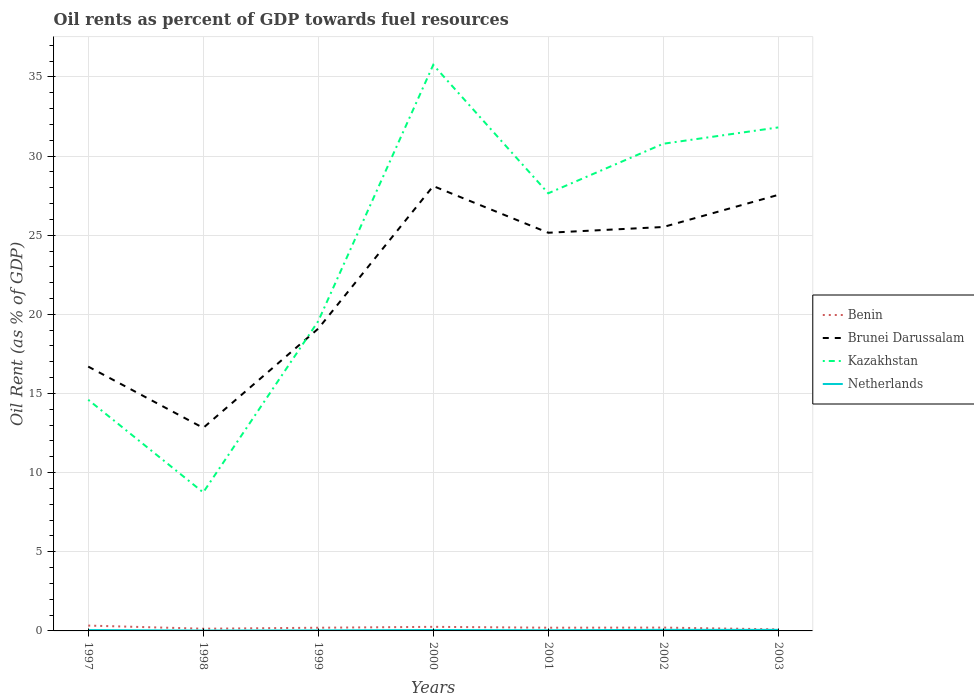Does the line corresponding to Kazakhstan intersect with the line corresponding to Benin?
Give a very brief answer. No. Is the number of lines equal to the number of legend labels?
Your answer should be very brief. Yes. Across all years, what is the maximum oil rent in Brunei Darussalam?
Keep it short and to the point. 12.83. In which year was the oil rent in Brunei Darussalam maximum?
Your answer should be very brief. 1998. What is the total oil rent in Kazakhstan in the graph?
Provide a succinct answer. -12.24. What is the difference between the highest and the second highest oil rent in Kazakhstan?
Keep it short and to the point. 27.01. What is the difference between the highest and the lowest oil rent in Brunei Darussalam?
Your response must be concise. 4. Is the oil rent in Kazakhstan strictly greater than the oil rent in Netherlands over the years?
Ensure brevity in your answer.  No. Does the graph contain any zero values?
Keep it short and to the point. No. Does the graph contain grids?
Make the answer very short. Yes. How many legend labels are there?
Offer a very short reply. 4. What is the title of the graph?
Your answer should be compact. Oil rents as percent of GDP towards fuel resources. Does "Middle income" appear as one of the legend labels in the graph?
Provide a short and direct response. No. What is the label or title of the X-axis?
Provide a short and direct response. Years. What is the label or title of the Y-axis?
Your answer should be very brief. Oil Rent (as % of GDP). What is the Oil Rent (as % of GDP) in Benin in 1997?
Give a very brief answer. 0.34. What is the Oil Rent (as % of GDP) in Brunei Darussalam in 1997?
Offer a very short reply. 16.7. What is the Oil Rent (as % of GDP) of Kazakhstan in 1997?
Offer a very short reply. 14.6. What is the Oil Rent (as % of GDP) in Netherlands in 1997?
Your answer should be very brief. 0.06. What is the Oil Rent (as % of GDP) in Benin in 1998?
Ensure brevity in your answer.  0.14. What is the Oil Rent (as % of GDP) in Brunei Darussalam in 1998?
Make the answer very short. 12.83. What is the Oil Rent (as % of GDP) in Kazakhstan in 1998?
Provide a short and direct response. 8.75. What is the Oil Rent (as % of GDP) in Netherlands in 1998?
Give a very brief answer. 0.02. What is the Oil Rent (as % of GDP) of Benin in 1999?
Offer a very short reply. 0.2. What is the Oil Rent (as % of GDP) in Brunei Darussalam in 1999?
Your answer should be compact. 19.1. What is the Oil Rent (as % of GDP) of Kazakhstan in 1999?
Your response must be concise. 19.57. What is the Oil Rent (as % of GDP) in Netherlands in 1999?
Give a very brief answer. 0.03. What is the Oil Rent (as % of GDP) in Benin in 2000?
Offer a terse response. 0.26. What is the Oil Rent (as % of GDP) of Brunei Darussalam in 2000?
Your response must be concise. 28.1. What is the Oil Rent (as % of GDP) of Kazakhstan in 2000?
Keep it short and to the point. 35.76. What is the Oil Rent (as % of GDP) in Netherlands in 2000?
Your response must be concise. 0.06. What is the Oil Rent (as % of GDP) of Benin in 2001?
Offer a very short reply. 0.2. What is the Oil Rent (as % of GDP) in Brunei Darussalam in 2001?
Provide a succinct answer. 25.15. What is the Oil Rent (as % of GDP) in Kazakhstan in 2001?
Make the answer very short. 27.65. What is the Oil Rent (as % of GDP) of Netherlands in 2001?
Provide a short and direct response. 0.04. What is the Oil Rent (as % of GDP) in Benin in 2002?
Your response must be concise. 0.21. What is the Oil Rent (as % of GDP) of Brunei Darussalam in 2002?
Keep it short and to the point. 25.52. What is the Oil Rent (as % of GDP) in Kazakhstan in 2002?
Keep it short and to the point. 30.78. What is the Oil Rent (as % of GDP) in Netherlands in 2002?
Ensure brevity in your answer.  0.07. What is the Oil Rent (as % of GDP) of Benin in 2003?
Keep it short and to the point. 0.1. What is the Oil Rent (as % of GDP) in Brunei Darussalam in 2003?
Offer a terse response. 27.55. What is the Oil Rent (as % of GDP) of Kazakhstan in 2003?
Provide a short and direct response. 31.81. What is the Oil Rent (as % of GDP) in Netherlands in 2003?
Provide a succinct answer. 0.07. Across all years, what is the maximum Oil Rent (as % of GDP) of Benin?
Your answer should be compact. 0.34. Across all years, what is the maximum Oil Rent (as % of GDP) in Brunei Darussalam?
Give a very brief answer. 28.1. Across all years, what is the maximum Oil Rent (as % of GDP) in Kazakhstan?
Ensure brevity in your answer.  35.76. Across all years, what is the maximum Oil Rent (as % of GDP) of Netherlands?
Offer a terse response. 0.07. Across all years, what is the minimum Oil Rent (as % of GDP) of Benin?
Offer a terse response. 0.1. Across all years, what is the minimum Oil Rent (as % of GDP) in Brunei Darussalam?
Offer a terse response. 12.83. Across all years, what is the minimum Oil Rent (as % of GDP) in Kazakhstan?
Offer a very short reply. 8.75. Across all years, what is the minimum Oil Rent (as % of GDP) in Netherlands?
Your answer should be very brief. 0.02. What is the total Oil Rent (as % of GDP) in Benin in the graph?
Your answer should be very brief. 1.45. What is the total Oil Rent (as % of GDP) of Brunei Darussalam in the graph?
Keep it short and to the point. 154.94. What is the total Oil Rent (as % of GDP) of Kazakhstan in the graph?
Give a very brief answer. 168.91. What is the total Oil Rent (as % of GDP) of Netherlands in the graph?
Offer a terse response. 0.35. What is the difference between the Oil Rent (as % of GDP) in Benin in 1997 and that in 1998?
Give a very brief answer. 0.2. What is the difference between the Oil Rent (as % of GDP) of Brunei Darussalam in 1997 and that in 1998?
Your answer should be compact. 3.87. What is the difference between the Oil Rent (as % of GDP) of Kazakhstan in 1997 and that in 1998?
Give a very brief answer. 5.85. What is the difference between the Oil Rent (as % of GDP) of Netherlands in 1997 and that in 1998?
Your response must be concise. 0.03. What is the difference between the Oil Rent (as % of GDP) of Benin in 1997 and that in 1999?
Ensure brevity in your answer.  0.14. What is the difference between the Oil Rent (as % of GDP) of Brunei Darussalam in 1997 and that in 1999?
Provide a short and direct response. -2.4. What is the difference between the Oil Rent (as % of GDP) in Kazakhstan in 1997 and that in 1999?
Make the answer very short. -4.96. What is the difference between the Oil Rent (as % of GDP) of Netherlands in 1997 and that in 1999?
Your answer should be compact. 0.02. What is the difference between the Oil Rent (as % of GDP) of Benin in 1997 and that in 2000?
Give a very brief answer. 0.08. What is the difference between the Oil Rent (as % of GDP) in Brunei Darussalam in 1997 and that in 2000?
Keep it short and to the point. -11.4. What is the difference between the Oil Rent (as % of GDP) in Kazakhstan in 1997 and that in 2000?
Your response must be concise. -21.16. What is the difference between the Oil Rent (as % of GDP) of Netherlands in 1997 and that in 2000?
Provide a short and direct response. -0. What is the difference between the Oil Rent (as % of GDP) of Benin in 1997 and that in 2001?
Ensure brevity in your answer.  0.13. What is the difference between the Oil Rent (as % of GDP) in Brunei Darussalam in 1997 and that in 2001?
Your response must be concise. -8.46. What is the difference between the Oil Rent (as % of GDP) of Kazakhstan in 1997 and that in 2001?
Give a very brief answer. -13.04. What is the difference between the Oil Rent (as % of GDP) of Netherlands in 1997 and that in 2001?
Give a very brief answer. 0.01. What is the difference between the Oil Rent (as % of GDP) in Benin in 1997 and that in 2002?
Provide a short and direct response. 0.13. What is the difference between the Oil Rent (as % of GDP) of Brunei Darussalam in 1997 and that in 2002?
Provide a short and direct response. -8.82. What is the difference between the Oil Rent (as % of GDP) in Kazakhstan in 1997 and that in 2002?
Keep it short and to the point. -16.17. What is the difference between the Oil Rent (as % of GDP) in Netherlands in 1997 and that in 2002?
Make the answer very short. -0.01. What is the difference between the Oil Rent (as % of GDP) in Benin in 1997 and that in 2003?
Your answer should be very brief. 0.24. What is the difference between the Oil Rent (as % of GDP) in Brunei Darussalam in 1997 and that in 2003?
Give a very brief answer. -10.85. What is the difference between the Oil Rent (as % of GDP) in Kazakhstan in 1997 and that in 2003?
Your answer should be compact. -17.2. What is the difference between the Oil Rent (as % of GDP) in Netherlands in 1997 and that in 2003?
Offer a very short reply. -0.01. What is the difference between the Oil Rent (as % of GDP) in Benin in 1998 and that in 1999?
Offer a terse response. -0.06. What is the difference between the Oil Rent (as % of GDP) of Brunei Darussalam in 1998 and that in 1999?
Provide a succinct answer. -6.27. What is the difference between the Oil Rent (as % of GDP) of Kazakhstan in 1998 and that in 1999?
Provide a short and direct response. -10.82. What is the difference between the Oil Rent (as % of GDP) of Netherlands in 1998 and that in 1999?
Your response must be concise. -0.01. What is the difference between the Oil Rent (as % of GDP) in Benin in 1998 and that in 2000?
Give a very brief answer. -0.12. What is the difference between the Oil Rent (as % of GDP) of Brunei Darussalam in 1998 and that in 2000?
Provide a succinct answer. -15.28. What is the difference between the Oil Rent (as % of GDP) in Kazakhstan in 1998 and that in 2000?
Keep it short and to the point. -27.01. What is the difference between the Oil Rent (as % of GDP) in Netherlands in 1998 and that in 2000?
Keep it short and to the point. -0.03. What is the difference between the Oil Rent (as % of GDP) of Benin in 1998 and that in 2001?
Your answer should be very brief. -0.06. What is the difference between the Oil Rent (as % of GDP) in Brunei Darussalam in 1998 and that in 2001?
Make the answer very short. -12.33. What is the difference between the Oil Rent (as % of GDP) of Kazakhstan in 1998 and that in 2001?
Provide a short and direct response. -18.9. What is the difference between the Oil Rent (as % of GDP) of Netherlands in 1998 and that in 2001?
Ensure brevity in your answer.  -0.02. What is the difference between the Oil Rent (as % of GDP) of Benin in 1998 and that in 2002?
Your response must be concise. -0.07. What is the difference between the Oil Rent (as % of GDP) of Brunei Darussalam in 1998 and that in 2002?
Your answer should be very brief. -12.69. What is the difference between the Oil Rent (as % of GDP) in Kazakhstan in 1998 and that in 2002?
Your answer should be very brief. -22.03. What is the difference between the Oil Rent (as % of GDP) in Netherlands in 1998 and that in 2002?
Keep it short and to the point. -0.04. What is the difference between the Oil Rent (as % of GDP) in Benin in 1998 and that in 2003?
Your response must be concise. 0.04. What is the difference between the Oil Rent (as % of GDP) in Brunei Darussalam in 1998 and that in 2003?
Give a very brief answer. -14.72. What is the difference between the Oil Rent (as % of GDP) in Kazakhstan in 1998 and that in 2003?
Offer a terse response. -23.06. What is the difference between the Oil Rent (as % of GDP) in Netherlands in 1998 and that in 2003?
Keep it short and to the point. -0.04. What is the difference between the Oil Rent (as % of GDP) of Benin in 1999 and that in 2000?
Give a very brief answer. -0.06. What is the difference between the Oil Rent (as % of GDP) in Brunei Darussalam in 1999 and that in 2000?
Your answer should be very brief. -9.01. What is the difference between the Oil Rent (as % of GDP) of Kazakhstan in 1999 and that in 2000?
Make the answer very short. -16.19. What is the difference between the Oil Rent (as % of GDP) in Netherlands in 1999 and that in 2000?
Keep it short and to the point. -0.03. What is the difference between the Oil Rent (as % of GDP) of Benin in 1999 and that in 2001?
Your answer should be compact. -0. What is the difference between the Oil Rent (as % of GDP) of Brunei Darussalam in 1999 and that in 2001?
Your answer should be very brief. -6.06. What is the difference between the Oil Rent (as % of GDP) in Kazakhstan in 1999 and that in 2001?
Provide a succinct answer. -8.08. What is the difference between the Oil Rent (as % of GDP) in Netherlands in 1999 and that in 2001?
Offer a very short reply. -0.01. What is the difference between the Oil Rent (as % of GDP) of Benin in 1999 and that in 2002?
Provide a succinct answer. -0.01. What is the difference between the Oil Rent (as % of GDP) in Brunei Darussalam in 1999 and that in 2002?
Provide a short and direct response. -6.42. What is the difference between the Oil Rent (as % of GDP) in Kazakhstan in 1999 and that in 2002?
Keep it short and to the point. -11.21. What is the difference between the Oil Rent (as % of GDP) of Netherlands in 1999 and that in 2002?
Offer a very short reply. -0.03. What is the difference between the Oil Rent (as % of GDP) of Benin in 1999 and that in 2003?
Offer a terse response. 0.1. What is the difference between the Oil Rent (as % of GDP) in Brunei Darussalam in 1999 and that in 2003?
Give a very brief answer. -8.45. What is the difference between the Oil Rent (as % of GDP) in Kazakhstan in 1999 and that in 2003?
Your answer should be compact. -12.24. What is the difference between the Oil Rent (as % of GDP) of Netherlands in 1999 and that in 2003?
Your answer should be very brief. -0.03. What is the difference between the Oil Rent (as % of GDP) of Benin in 2000 and that in 2001?
Provide a succinct answer. 0.05. What is the difference between the Oil Rent (as % of GDP) in Brunei Darussalam in 2000 and that in 2001?
Ensure brevity in your answer.  2.95. What is the difference between the Oil Rent (as % of GDP) of Kazakhstan in 2000 and that in 2001?
Provide a short and direct response. 8.11. What is the difference between the Oil Rent (as % of GDP) in Netherlands in 2000 and that in 2001?
Offer a very short reply. 0.01. What is the difference between the Oil Rent (as % of GDP) of Benin in 2000 and that in 2002?
Your answer should be compact. 0.05. What is the difference between the Oil Rent (as % of GDP) in Brunei Darussalam in 2000 and that in 2002?
Your response must be concise. 2.59. What is the difference between the Oil Rent (as % of GDP) in Kazakhstan in 2000 and that in 2002?
Offer a terse response. 4.98. What is the difference between the Oil Rent (as % of GDP) of Netherlands in 2000 and that in 2002?
Offer a very short reply. -0.01. What is the difference between the Oil Rent (as % of GDP) of Benin in 2000 and that in 2003?
Give a very brief answer. 0.16. What is the difference between the Oil Rent (as % of GDP) of Brunei Darussalam in 2000 and that in 2003?
Provide a short and direct response. 0.56. What is the difference between the Oil Rent (as % of GDP) in Kazakhstan in 2000 and that in 2003?
Offer a terse response. 3.95. What is the difference between the Oil Rent (as % of GDP) of Netherlands in 2000 and that in 2003?
Keep it short and to the point. -0.01. What is the difference between the Oil Rent (as % of GDP) in Benin in 2001 and that in 2002?
Provide a short and direct response. -0.01. What is the difference between the Oil Rent (as % of GDP) of Brunei Darussalam in 2001 and that in 2002?
Offer a very short reply. -0.36. What is the difference between the Oil Rent (as % of GDP) of Kazakhstan in 2001 and that in 2002?
Keep it short and to the point. -3.13. What is the difference between the Oil Rent (as % of GDP) in Netherlands in 2001 and that in 2002?
Keep it short and to the point. -0.02. What is the difference between the Oil Rent (as % of GDP) of Benin in 2001 and that in 2003?
Your answer should be compact. 0.1. What is the difference between the Oil Rent (as % of GDP) of Brunei Darussalam in 2001 and that in 2003?
Your answer should be compact. -2.39. What is the difference between the Oil Rent (as % of GDP) of Kazakhstan in 2001 and that in 2003?
Give a very brief answer. -4.16. What is the difference between the Oil Rent (as % of GDP) in Netherlands in 2001 and that in 2003?
Offer a terse response. -0.02. What is the difference between the Oil Rent (as % of GDP) of Benin in 2002 and that in 2003?
Give a very brief answer. 0.11. What is the difference between the Oil Rent (as % of GDP) in Brunei Darussalam in 2002 and that in 2003?
Give a very brief answer. -2.03. What is the difference between the Oil Rent (as % of GDP) of Kazakhstan in 2002 and that in 2003?
Offer a terse response. -1.03. What is the difference between the Oil Rent (as % of GDP) in Netherlands in 2002 and that in 2003?
Your answer should be very brief. -0. What is the difference between the Oil Rent (as % of GDP) in Benin in 1997 and the Oil Rent (as % of GDP) in Brunei Darussalam in 1998?
Your answer should be very brief. -12.49. What is the difference between the Oil Rent (as % of GDP) in Benin in 1997 and the Oil Rent (as % of GDP) in Kazakhstan in 1998?
Your answer should be compact. -8.41. What is the difference between the Oil Rent (as % of GDP) of Benin in 1997 and the Oil Rent (as % of GDP) of Netherlands in 1998?
Offer a very short reply. 0.31. What is the difference between the Oil Rent (as % of GDP) of Brunei Darussalam in 1997 and the Oil Rent (as % of GDP) of Kazakhstan in 1998?
Your answer should be compact. 7.95. What is the difference between the Oil Rent (as % of GDP) in Brunei Darussalam in 1997 and the Oil Rent (as % of GDP) in Netherlands in 1998?
Offer a very short reply. 16.68. What is the difference between the Oil Rent (as % of GDP) of Kazakhstan in 1997 and the Oil Rent (as % of GDP) of Netherlands in 1998?
Offer a terse response. 14.58. What is the difference between the Oil Rent (as % of GDP) of Benin in 1997 and the Oil Rent (as % of GDP) of Brunei Darussalam in 1999?
Your response must be concise. -18.76. What is the difference between the Oil Rent (as % of GDP) in Benin in 1997 and the Oil Rent (as % of GDP) in Kazakhstan in 1999?
Offer a very short reply. -19.23. What is the difference between the Oil Rent (as % of GDP) of Benin in 1997 and the Oil Rent (as % of GDP) of Netherlands in 1999?
Your answer should be very brief. 0.3. What is the difference between the Oil Rent (as % of GDP) of Brunei Darussalam in 1997 and the Oil Rent (as % of GDP) of Kazakhstan in 1999?
Provide a short and direct response. -2.87. What is the difference between the Oil Rent (as % of GDP) in Brunei Darussalam in 1997 and the Oil Rent (as % of GDP) in Netherlands in 1999?
Offer a very short reply. 16.67. What is the difference between the Oil Rent (as % of GDP) of Kazakhstan in 1997 and the Oil Rent (as % of GDP) of Netherlands in 1999?
Keep it short and to the point. 14.57. What is the difference between the Oil Rent (as % of GDP) of Benin in 1997 and the Oil Rent (as % of GDP) of Brunei Darussalam in 2000?
Your response must be concise. -27.77. What is the difference between the Oil Rent (as % of GDP) of Benin in 1997 and the Oil Rent (as % of GDP) of Kazakhstan in 2000?
Provide a succinct answer. -35.42. What is the difference between the Oil Rent (as % of GDP) in Benin in 1997 and the Oil Rent (as % of GDP) in Netherlands in 2000?
Provide a succinct answer. 0.28. What is the difference between the Oil Rent (as % of GDP) of Brunei Darussalam in 1997 and the Oil Rent (as % of GDP) of Kazakhstan in 2000?
Provide a succinct answer. -19.06. What is the difference between the Oil Rent (as % of GDP) of Brunei Darussalam in 1997 and the Oil Rent (as % of GDP) of Netherlands in 2000?
Your response must be concise. 16.64. What is the difference between the Oil Rent (as % of GDP) of Kazakhstan in 1997 and the Oil Rent (as % of GDP) of Netherlands in 2000?
Your answer should be very brief. 14.55. What is the difference between the Oil Rent (as % of GDP) in Benin in 1997 and the Oil Rent (as % of GDP) in Brunei Darussalam in 2001?
Your response must be concise. -24.82. What is the difference between the Oil Rent (as % of GDP) in Benin in 1997 and the Oil Rent (as % of GDP) in Kazakhstan in 2001?
Provide a succinct answer. -27.31. What is the difference between the Oil Rent (as % of GDP) in Benin in 1997 and the Oil Rent (as % of GDP) in Netherlands in 2001?
Offer a terse response. 0.29. What is the difference between the Oil Rent (as % of GDP) of Brunei Darussalam in 1997 and the Oil Rent (as % of GDP) of Kazakhstan in 2001?
Offer a very short reply. -10.95. What is the difference between the Oil Rent (as % of GDP) in Brunei Darussalam in 1997 and the Oil Rent (as % of GDP) in Netherlands in 2001?
Your answer should be very brief. 16.66. What is the difference between the Oil Rent (as % of GDP) in Kazakhstan in 1997 and the Oil Rent (as % of GDP) in Netherlands in 2001?
Offer a very short reply. 14.56. What is the difference between the Oil Rent (as % of GDP) of Benin in 1997 and the Oil Rent (as % of GDP) of Brunei Darussalam in 2002?
Your response must be concise. -25.18. What is the difference between the Oil Rent (as % of GDP) in Benin in 1997 and the Oil Rent (as % of GDP) in Kazakhstan in 2002?
Your answer should be compact. -30.44. What is the difference between the Oil Rent (as % of GDP) of Benin in 1997 and the Oil Rent (as % of GDP) of Netherlands in 2002?
Ensure brevity in your answer.  0.27. What is the difference between the Oil Rent (as % of GDP) of Brunei Darussalam in 1997 and the Oil Rent (as % of GDP) of Kazakhstan in 2002?
Provide a short and direct response. -14.08. What is the difference between the Oil Rent (as % of GDP) of Brunei Darussalam in 1997 and the Oil Rent (as % of GDP) of Netherlands in 2002?
Ensure brevity in your answer.  16.63. What is the difference between the Oil Rent (as % of GDP) of Kazakhstan in 1997 and the Oil Rent (as % of GDP) of Netherlands in 2002?
Your answer should be very brief. 14.54. What is the difference between the Oil Rent (as % of GDP) of Benin in 1997 and the Oil Rent (as % of GDP) of Brunei Darussalam in 2003?
Your answer should be very brief. -27.21. What is the difference between the Oil Rent (as % of GDP) in Benin in 1997 and the Oil Rent (as % of GDP) in Kazakhstan in 2003?
Provide a short and direct response. -31.47. What is the difference between the Oil Rent (as % of GDP) of Benin in 1997 and the Oil Rent (as % of GDP) of Netherlands in 2003?
Ensure brevity in your answer.  0.27. What is the difference between the Oil Rent (as % of GDP) of Brunei Darussalam in 1997 and the Oil Rent (as % of GDP) of Kazakhstan in 2003?
Offer a very short reply. -15.11. What is the difference between the Oil Rent (as % of GDP) in Brunei Darussalam in 1997 and the Oil Rent (as % of GDP) in Netherlands in 2003?
Provide a short and direct response. 16.63. What is the difference between the Oil Rent (as % of GDP) of Kazakhstan in 1997 and the Oil Rent (as % of GDP) of Netherlands in 2003?
Provide a short and direct response. 14.54. What is the difference between the Oil Rent (as % of GDP) in Benin in 1998 and the Oil Rent (as % of GDP) in Brunei Darussalam in 1999?
Offer a very short reply. -18.96. What is the difference between the Oil Rent (as % of GDP) in Benin in 1998 and the Oil Rent (as % of GDP) in Kazakhstan in 1999?
Provide a short and direct response. -19.43. What is the difference between the Oil Rent (as % of GDP) of Benin in 1998 and the Oil Rent (as % of GDP) of Netherlands in 1999?
Your answer should be very brief. 0.11. What is the difference between the Oil Rent (as % of GDP) of Brunei Darussalam in 1998 and the Oil Rent (as % of GDP) of Kazakhstan in 1999?
Give a very brief answer. -6.74. What is the difference between the Oil Rent (as % of GDP) of Brunei Darussalam in 1998 and the Oil Rent (as % of GDP) of Netherlands in 1999?
Offer a terse response. 12.79. What is the difference between the Oil Rent (as % of GDP) of Kazakhstan in 1998 and the Oil Rent (as % of GDP) of Netherlands in 1999?
Keep it short and to the point. 8.72. What is the difference between the Oil Rent (as % of GDP) of Benin in 1998 and the Oil Rent (as % of GDP) of Brunei Darussalam in 2000?
Give a very brief answer. -27.96. What is the difference between the Oil Rent (as % of GDP) of Benin in 1998 and the Oil Rent (as % of GDP) of Kazakhstan in 2000?
Your answer should be very brief. -35.62. What is the difference between the Oil Rent (as % of GDP) in Benin in 1998 and the Oil Rent (as % of GDP) in Netherlands in 2000?
Your answer should be compact. 0.08. What is the difference between the Oil Rent (as % of GDP) in Brunei Darussalam in 1998 and the Oil Rent (as % of GDP) in Kazakhstan in 2000?
Offer a terse response. -22.93. What is the difference between the Oil Rent (as % of GDP) of Brunei Darussalam in 1998 and the Oil Rent (as % of GDP) of Netherlands in 2000?
Offer a very short reply. 12.77. What is the difference between the Oil Rent (as % of GDP) of Kazakhstan in 1998 and the Oil Rent (as % of GDP) of Netherlands in 2000?
Your response must be concise. 8.69. What is the difference between the Oil Rent (as % of GDP) of Benin in 1998 and the Oil Rent (as % of GDP) of Brunei Darussalam in 2001?
Your answer should be very brief. -25.01. What is the difference between the Oil Rent (as % of GDP) of Benin in 1998 and the Oil Rent (as % of GDP) of Kazakhstan in 2001?
Offer a terse response. -27.51. What is the difference between the Oil Rent (as % of GDP) in Benin in 1998 and the Oil Rent (as % of GDP) in Netherlands in 2001?
Provide a succinct answer. 0.1. What is the difference between the Oil Rent (as % of GDP) of Brunei Darussalam in 1998 and the Oil Rent (as % of GDP) of Kazakhstan in 2001?
Make the answer very short. -14.82. What is the difference between the Oil Rent (as % of GDP) of Brunei Darussalam in 1998 and the Oil Rent (as % of GDP) of Netherlands in 2001?
Offer a very short reply. 12.78. What is the difference between the Oil Rent (as % of GDP) of Kazakhstan in 1998 and the Oil Rent (as % of GDP) of Netherlands in 2001?
Offer a very short reply. 8.71. What is the difference between the Oil Rent (as % of GDP) of Benin in 1998 and the Oil Rent (as % of GDP) of Brunei Darussalam in 2002?
Keep it short and to the point. -25.38. What is the difference between the Oil Rent (as % of GDP) in Benin in 1998 and the Oil Rent (as % of GDP) in Kazakhstan in 2002?
Offer a very short reply. -30.64. What is the difference between the Oil Rent (as % of GDP) in Benin in 1998 and the Oil Rent (as % of GDP) in Netherlands in 2002?
Ensure brevity in your answer.  0.07. What is the difference between the Oil Rent (as % of GDP) of Brunei Darussalam in 1998 and the Oil Rent (as % of GDP) of Kazakhstan in 2002?
Give a very brief answer. -17.95. What is the difference between the Oil Rent (as % of GDP) in Brunei Darussalam in 1998 and the Oil Rent (as % of GDP) in Netherlands in 2002?
Offer a very short reply. 12.76. What is the difference between the Oil Rent (as % of GDP) in Kazakhstan in 1998 and the Oil Rent (as % of GDP) in Netherlands in 2002?
Ensure brevity in your answer.  8.68. What is the difference between the Oil Rent (as % of GDP) in Benin in 1998 and the Oil Rent (as % of GDP) in Brunei Darussalam in 2003?
Keep it short and to the point. -27.41. What is the difference between the Oil Rent (as % of GDP) in Benin in 1998 and the Oil Rent (as % of GDP) in Kazakhstan in 2003?
Provide a succinct answer. -31.67. What is the difference between the Oil Rent (as % of GDP) in Benin in 1998 and the Oil Rent (as % of GDP) in Netherlands in 2003?
Provide a short and direct response. 0.07. What is the difference between the Oil Rent (as % of GDP) in Brunei Darussalam in 1998 and the Oil Rent (as % of GDP) in Kazakhstan in 2003?
Your answer should be compact. -18.98. What is the difference between the Oil Rent (as % of GDP) in Brunei Darussalam in 1998 and the Oil Rent (as % of GDP) in Netherlands in 2003?
Your response must be concise. 12.76. What is the difference between the Oil Rent (as % of GDP) in Kazakhstan in 1998 and the Oil Rent (as % of GDP) in Netherlands in 2003?
Your response must be concise. 8.68. What is the difference between the Oil Rent (as % of GDP) of Benin in 1999 and the Oil Rent (as % of GDP) of Brunei Darussalam in 2000?
Your answer should be very brief. -27.9. What is the difference between the Oil Rent (as % of GDP) of Benin in 1999 and the Oil Rent (as % of GDP) of Kazakhstan in 2000?
Keep it short and to the point. -35.56. What is the difference between the Oil Rent (as % of GDP) in Benin in 1999 and the Oil Rent (as % of GDP) in Netherlands in 2000?
Your answer should be very brief. 0.14. What is the difference between the Oil Rent (as % of GDP) of Brunei Darussalam in 1999 and the Oil Rent (as % of GDP) of Kazakhstan in 2000?
Give a very brief answer. -16.66. What is the difference between the Oil Rent (as % of GDP) of Brunei Darussalam in 1999 and the Oil Rent (as % of GDP) of Netherlands in 2000?
Your answer should be compact. 19.04. What is the difference between the Oil Rent (as % of GDP) of Kazakhstan in 1999 and the Oil Rent (as % of GDP) of Netherlands in 2000?
Your answer should be very brief. 19.51. What is the difference between the Oil Rent (as % of GDP) in Benin in 1999 and the Oil Rent (as % of GDP) in Brunei Darussalam in 2001?
Keep it short and to the point. -24.95. What is the difference between the Oil Rent (as % of GDP) of Benin in 1999 and the Oil Rent (as % of GDP) of Kazakhstan in 2001?
Provide a short and direct response. -27.45. What is the difference between the Oil Rent (as % of GDP) in Benin in 1999 and the Oil Rent (as % of GDP) in Netherlands in 2001?
Offer a terse response. 0.16. What is the difference between the Oil Rent (as % of GDP) in Brunei Darussalam in 1999 and the Oil Rent (as % of GDP) in Kazakhstan in 2001?
Your response must be concise. -8.55. What is the difference between the Oil Rent (as % of GDP) of Brunei Darussalam in 1999 and the Oil Rent (as % of GDP) of Netherlands in 2001?
Offer a terse response. 19.05. What is the difference between the Oil Rent (as % of GDP) of Kazakhstan in 1999 and the Oil Rent (as % of GDP) of Netherlands in 2001?
Offer a terse response. 19.52. What is the difference between the Oil Rent (as % of GDP) in Benin in 1999 and the Oil Rent (as % of GDP) in Brunei Darussalam in 2002?
Your answer should be very brief. -25.32. What is the difference between the Oil Rent (as % of GDP) in Benin in 1999 and the Oil Rent (as % of GDP) in Kazakhstan in 2002?
Provide a short and direct response. -30.58. What is the difference between the Oil Rent (as % of GDP) in Benin in 1999 and the Oil Rent (as % of GDP) in Netherlands in 2002?
Your response must be concise. 0.13. What is the difference between the Oil Rent (as % of GDP) of Brunei Darussalam in 1999 and the Oil Rent (as % of GDP) of Kazakhstan in 2002?
Ensure brevity in your answer.  -11.68. What is the difference between the Oil Rent (as % of GDP) of Brunei Darussalam in 1999 and the Oil Rent (as % of GDP) of Netherlands in 2002?
Ensure brevity in your answer.  19.03. What is the difference between the Oil Rent (as % of GDP) of Kazakhstan in 1999 and the Oil Rent (as % of GDP) of Netherlands in 2002?
Offer a terse response. 19.5. What is the difference between the Oil Rent (as % of GDP) in Benin in 1999 and the Oil Rent (as % of GDP) in Brunei Darussalam in 2003?
Your answer should be very brief. -27.35. What is the difference between the Oil Rent (as % of GDP) of Benin in 1999 and the Oil Rent (as % of GDP) of Kazakhstan in 2003?
Ensure brevity in your answer.  -31.61. What is the difference between the Oil Rent (as % of GDP) of Benin in 1999 and the Oil Rent (as % of GDP) of Netherlands in 2003?
Ensure brevity in your answer.  0.13. What is the difference between the Oil Rent (as % of GDP) of Brunei Darussalam in 1999 and the Oil Rent (as % of GDP) of Kazakhstan in 2003?
Provide a succinct answer. -12.71. What is the difference between the Oil Rent (as % of GDP) of Brunei Darussalam in 1999 and the Oil Rent (as % of GDP) of Netherlands in 2003?
Make the answer very short. 19.03. What is the difference between the Oil Rent (as % of GDP) of Kazakhstan in 1999 and the Oil Rent (as % of GDP) of Netherlands in 2003?
Offer a very short reply. 19.5. What is the difference between the Oil Rent (as % of GDP) in Benin in 2000 and the Oil Rent (as % of GDP) in Brunei Darussalam in 2001?
Your answer should be very brief. -24.9. What is the difference between the Oil Rent (as % of GDP) of Benin in 2000 and the Oil Rent (as % of GDP) of Kazakhstan in 2001?
Provide a succinct answer. -27.39. What is the difference between the Oil Rent (as % of GDP) of Benin in 2000 and the Oil Rent (as % of GDP) of Netherlands in 2001?
Provide a short and direct response. 0.21. What is the difference between the Oil Rent (as % of GDP) of Brunei Darussalam in 2000 and the Oil Rent (as % of GDP) of Kazakhstan in 2001?
Your response must be concise. 0.46. What is the difference between the Oil Rent (as % of GDP) of Brunei Darussalam in 2000 and the Oil Rent (as % of GDP) of Netherlands in 2001?
Your response must be concise. 28.06. What is the difference between the Oil Rent (as % of GDP) of Kazakhstan in 2000 and the Oil Rent (as % of GDP) of Netherlands in 2001?
Your response must be concise. 35.72. What is the difference between the Oil Rent (as % of GDP) in Benin in 2000 and the Oil Rent (as % of GDP) in Brunei Darussalam in 2002?
Provide a short and direct response. -25.26. What is the difference between the Oil Rent (as % of GDP) of Benin in 2000 and the Oil Rent (as % of GDP) of Kazakhstan in 2002?
Keep it short and to the point. -30.52. What is the difference between the Oil Rent (as % of GDP) of Benin in 2000 and the Oil Rent (as % of GDP) of Netherlands in 2002?
Make the answer very short. 0.19. What is the difference between the Oil Rent (as % of GDP) in Brunei Darussalam in 2000 and the Oil Rent (as % of GDP) in Kazakhstan in 2002?
Provide a short and direct response. -2.67. What is the difference between the Oil Rent (as % of GDP) in Brunei Darussalam in 2000 and the Oil Rent (as % of GDP) in Netherlands in 2002?
Ensure brevity in your answer.  28.04. What is the difference between the Oil Rent (as % of GDP) in Kazakhstan in 2000 and the Oil Rent (as % of GDP) in Netherlands in 2002?
Provide a succinct answer. 35.69. What is the difference between the Oil Rent (as % of GDP) of Benin in 2000 and the Oil Rent (as % of GDP) of Brunei Darussalam in 2003?
Provide a succinct answer. -27.29. What is the difference between the Oil Rent (as % of GDP) of Benin in 2000 and the Oil Rent (as % of GDP) of Kazakhstan in 2003?
Keep it short and to the point. -31.55. What is the difference between the Oil Rent (as % of GDP) in Benin in 2000 and the Oil Rent (as % of GDP) in Netherlands in 2003?
Your response must be concise. 0.19. What is the difference between the Oil Rent (as % of GDP) in Brunei Darussalam in 2000 and the Oil Rent (as % of GDP) in Kazakhstan in 2003?
Keep it short and to the point. -3.7. What is the difference between the Oil Rent (as % of GDP) in Brunei Darussalam in 2000 and the Oil Rent (as % of GDP) in Netherlands in 2003?
Offer a terse response. 28.04. What is the difference between the Oil Rent (as % of GDP) of Kazakhstan in 2000 and the Oil Rent (as % of GDP) of Netherlands in 2003?
Keep it short and to the point. 35.69. What is the difference between the Oil Rent (as % of GDP) of Benin in 2001 and the Oil Rent (as % of GDP) of Brunei Darussalam in 2002?
Give a very brief answer. -25.31. What is the difference between the Oil Rent (as % of GDP) of Benin in 2001 and the Oil Rent (as % of GDP) of Kazakhstan in 2002?
Your answer should be very brief. -30.57. What is the difference between the Oil Rent (as % of GDP) of Benin in 2001 and the Oil Rent (as % of GDP) of Netherlands in 2002?
Give a very brief answer. 0.14. What is the difference between the Oil Rent (as % of GDP) in Brunei Darussalam in 2001 and the Oil Rent (as % of GDP) in Kazakhstan in 2002?
Offer a very short reply. -5.62. What is the difference between the Oil Rent (as % of GDP) in Brunei Darussalam in 2001 and the Oil Rent (as % of GDP) in Netherlands in 2002?
Provide a succinct answer. 25.09. What is the difference between the Oil Rent (as % of GDP) in Kazakhstan in 2001 and the Oil Rent (as % of GDP) in Netherlands in 2002?
Keep it short and to the point. 27.58. What is the difference between the Oil Rent (as % of GDP) in Benin in 2001 and the Oil Rent (as % of GDP) in Brunei Darussalam in 2003?
Keep it short and to the point. -27.34. What is the difference between the Oil Rent (as % of GDP) in Benin in 2001 and the Oil Rent (as % of GDP) in Kazakhstan in 2003?
Your answer should be very brief. -31.6. What is the difference between the Oil Rent (as % of GDP) of Benin in 2001 and the Oil Rent (as % of GDP) of Netherlands in 2003?
Provide a short and direct response. 0.14. What is the difference between the Oil Rent (as % of GDP) of Brunei Darussalam in 2001 and the Oil Rent (as % of GDP) of Kazakhstan in 2003?
Offer a terse response. -6.65. What is the difference between the Oil Rent (as % of GDP) in Brunei Darussalam in 2001 and the Oil Rent (as % of GDP) in Netherlands in 2003?
Ensure brevity in your answer.  25.09. What is the difference between the Oil Rent (as % of GDP) in Kazakhstan in 2001 and the Oil Rent (as % of GDP) in Netherlands in 2003?
Your response must be concise. 27.58. What is the difference between the Oil Rent (as % of GDP) in Benin in 2002 and the Oil Rent (as % of GDP) in Brunei Darussalam in 2003?
Give a very brief answer. -27.34. What is the difference between the Oil Rent (as % of GDP) of Benin in 2002 and the Oil Rent (as % of GDP) of Kazakhstan in 2003?
Provide a succinct answer. -31.6. What is the difference between the Oil Rent (as % of GDP) in Benin in 2002 and the Oil Rent (as % of GDP) in Netherlands in 2003?
Keep it short and to the point. 0.14. What is the difference between the Oil Rent (as % of GDP) of Brunei Darussalam in 2002 and the Oil Rent (as % of GDP) of Kazakhstan in 2003?
Keep it short and to the point. -6.29. What is the difference between the Oil Rent (as % of GDP) of Brunei Darussalam in 2002 and the Oil Rent (as % of GDP) of Netherlands in 2003?
Give a very brief answer. 25.45. What is the difference between the Oil Rent (as % of GDP) in Kazakhstan in 2002 and the Oil Rent (as % of GDP) in Netherlands in 2003?
Your answer should be compact. 30.71. What is the average Oil Rent (as % of GDP) in Benin per year?
Provide a short and direct response. 0.21. What is the average Oil Rent (as % of GDP) in Brunei Darussalam per year?
Ensure brevity in your answer.  22.13. What is the average Oil Rent (as % of GDP) in Kazakhstan per year?
Your answer should be very brief. 24.13. What is the average Oil Rent (as % of GDP) in Netherlands per year?
Provide a short and direct response. 0.05. In the year 1997, what is the difference between the Oil Rent (as % of GDP) in Benin and Oil Rent (as % of GDP) in Brunei Darussalam?
Offer a terse response. -16.36. In the year 1997, what is the difference between the Oil Rent (as % of GDP) in Benin and Oil Rent (as % of GDP) in Kazakhstan?
Your response must be concise. -14.27. In the year 1997, what is the difference between the Oil Rent (as % of GDP) of Benin and Oil Rent (as % of GDP) of Netherlands?
Keep it short and to the point. 0.28. In the year 1997, what is the difference between the Oil Rent (as % of GDP) of Brunei Darussalam and Oil Rent (as % of GDP) of Kazakhstan?
Keep it short and to the point. 2.1. In the year 1997, what is the difference between the Oil Rent (as % of GDP) in Brunei Darussalam and Oil Rent (as % of GDP) in Netherlands?
Your answer should be compact. 16.64. In the year 1997, what is the difference between the Oil Rent (as % of GDP) in Kazakhstan and Oil Rent (as % of GDP) in Netherlands?
Ensure brevity in your answer.  14.55. In the year 1998, what is the difference between the Oil Rent (as % of GDP) of Benin and Oil Rent (as % of GDP) of Brunei Darussalam?
Give a very brief answer. -12.69. In the year 1998, what is the difference between the Oil Rent (as % of GDP) in Benin and Oil Rent (as % of GDP) in Kazakhstan?
Offer a very short reply. -8.61. In the year 1998, what is the difference between the Oil Rent (as % of GDP) in Benin and Oil Rent (as % of GDP) in Netherlands?
Keep it short and to the point. 0.12. In the year 1998, what is the difference between the Oil Rent (as % of GDP) of Brunei Darussalam and Oil Rent (as % of GDP) of Kazakhstan?
Offer a terse response. 4.08. In the year 1998, what is the difference between the Oil Rent (as % of GDP) of Brunei Darussalam and Oil Rent (as % of GDP) of Netherlands?
Your answer should be very brief. 12.8. In the year 1998, what is the difference between the Oil Rent (as % of GDP) in Kazakhstan and Oil Rent (as % of GDP) in Netherlands?
Keep it short and to the point. 8.73. In the year 1999, what is the difference between the Oil Rent (as % of GDP) in Benin and Oil Rent (as % of GDP) in Brunei Darussalam?
Ensure brevity in your answer.  -18.89. In the year 1999, what is the difference between the Oil Rent (as % of GDP) of Benin and Oil Rent (as % of GDP) of Kazakhstan?
Offer a terse response. -19.37. In the year 1999, what is the difference between the Oil Rent (as % of GDP) of Benin and Oil Rent (as % of GDP) of Netherlands?
Offer a very short reply. 0.17. In the year 1999, what is the difference between the Oil Rent (as % of GDP) of Brunei Darussalam and Oil Rent (as % of GDP) of Kazakhstan?
Keep it short and to the point. -0.47. In the year 1999, what is the difference between the Oil Rent (as % of GDP) of Brunei Darussalam and Oil Rent (as % of GDP) of Netherlands?
Offer a terse response. 19.06. In the year 1999, what is the difference between the Oil Rent (as % of GDP) in Kazakhstan and Oil Rent (as % of GDP) in Netherlands?
Provide a succinct answer. 19.54. In the year 2000, what is the difference between the Oil Rent (as % of GDP) of Benin and Oil Rent (as % of GDP) of Brunei Darussalam?
Provide a short and direct response. -27.85. In the year 2000, what is the difference between the Oil Rent (as % of GDP) of Benin and Oil Rent (as % of GDP) of Kazakhstan?
Keep it short and to the point. -35.5. In the year 2000, what is the difference between the Oil Rent (as % of GDP) of Benin and Oil Rent (as % of GDP) of Netherlands?
Make the answer very short. 0.2. In the year 2000, what is the difference between the Oil Rent (as % of GDP) of Brunei Darussalam and Oil Rent (as % of GDP) of Kazakhstan?
Offer a very short reply. -7.66. In the year 2000, what is the difference between the Oil Rent (as % of GDP) in Brunei Darussalam and Oil Rent (as % of GDP) in Netherlands?
Provide a short and direct response. 28.04. In the year 2000, what is the difference between the Oil Rent (as % of GDP) of Kazakhstan and Oil Rent (as % of GDP) of Netherlands?
Provide a succinct answer. 35.7. In the year 2001, what is the difference between the Oil Rent (as % of GDP) of Benin and Oil Rent (as % of GDP) of Brunei Darussalam?
Provide a succinct answer. -24.95. In the year 2001, what is the difference between the Oil Rent (as % of GDP) of Benin and Oil Rent (as % of GDP) of Kazakhstan?
Ensure brevity in your answer.  -27.44. In the year 2001, what is the difference between the Oil Rent (as % of GDP) in Benin and Oil Rent (as % of GDP) in Netherlands?
Ensure brevity in your answer.  0.16. In the year 2001, what is the difference between the Oil Rent (as % of GDP) of Brunei Darussalam and Oil Rent (as % of GDP) of Kazakhstan?
Provide a short and direct response. -2.49. In the year 2001, what is the difference between the Oil Rent (as % of GDP) of Brunei Darussalam and Oil Rent (as % of GDP) of Netherlands?
Keep it short and to the point. 25.11. In the year 2001, what is the difference between the Oil Rent (as % of GDP) in Kazakhstan and Oil Rent (as % of GDP) in Netherlands?
Your answer should be very brief. 27.6. In the year 2002, what is the difference between the Oil Rent (as % of GDP) in Benin and Oil Rent (as % of GDP) in Brunei Darussalam?
Provide a succinct answer. -25.31. In the year 2002, what is the difference between the Oil Rent (as % of GDP) of Benin and Oil Rent (as % of GDP) of Kazakhstan?
Offer a terse response. -30.57. In the year 2002, what is the difference between the Oil Rent (as % of GDP) of Benin and Oil Rent (as % of GDP) of Netherlands?
Give a very brief answer. 0.14. In the year 2002, what is the difference between the Oil Rent (as % of GDP) of Brunei Darussalam and Oil Rent (as % of GDP) of Kazakhstan?
Provide a short and direct response. -5.26. In the year 2002, what is the difference between the Oil Rent (as % of GDP) in Brunei Darussalam and Oil Rent (as % of GDP) in Netherlands?
Provide a succinct answer. 25.45. In the year 2002, what is the difference between the Oil Rent (as % of GDP) of Kazakhstan and Oil Rent (as % of GDP) of Netherlands?
Provide a short and direct response. 30.71. In the year 2003, what is the difference between the Oil Rent (as % of GDP) of Benin and Oil Rent (as % of GDP) of Brunei Darussalam?
Your answer should be very brief. -27.45. In the year 2003, what is the difference between the Oil Rent (as % of GDP) in Benin and Oil Rent (as % of GDP) in Kazakhstan?
Your answer should be compact. -31.71. In the year 2003, what is the difference between the Oil Rent (as % of GDP) in Benin and Oil Rent (as % of GDP) in Netherlands?
Provide a succinct answer. 0.03. In the year 2003, what is the difference between the Oil Rent (as % of GDP) of Brunei Darussalam and Oil Rent (as % of GDP) of Kazakhstan?
Provide a succinct answer. -4.26. In the year 2003, what is the difference between the Oil Rent (as % of GDP) in Brunei Darussalam and Oil Rent (as % of GDP) in Netherlands?
Keep it short and to the point. 27.48. In the year 2003, what is the difference between the Oil Rent (as % of GDP) in Kazakhstan and Oil Rent (as % of GDP) in Netherlands?
Offer a terse response. 31.74. What is the ratio of the Oil Rent (as % of GDP) in Benin in 1997 to that in 1998?
Offer a terse response. 2.4. What is the ratio of the Oil Rent (as % of GDP) in Brunei Darussalam in 1997 to that in 1998?
Provide a short and direct response. 1.3. What is the ratio of the Oil Rent (as % of GDP) in Kazakhstan in 1997 to that in 1998?
Keep it short and to the point. 1.67. What is the ratio of the Oil Rent (as % of GDP) in Netherlands in 1997 to that in 1998?
Provide a short and direct response. 2.27. What is the ratio of the Oil Rent (as % of GDP) in Benin in 1997 to that in 1999?
Provide a succinct answer. 1.67. What is the ratio of the Oil Rent (as % of GDP) in Brunei Darussalam in 1997 to that in 1999?
Keep it short and to the point. 0.87. What is the ratio of the Oil Rent (as % of GDP) of Kazakhstan in 1997 to that in 1999?
Your response must be concise. 0.75. What is the ratio of the Oil Rent (as % of GDP) in Netherlands in 1997 to that in 1999?
Make the answer very short. 1.67. What is the ratio of the Oil Rent (as % of GDP) in Benin in 1997 to that in 2000?
Your response must be concise. 1.31. What is the ratio of the Oil Rent (as % of GDP) of Brunei Darussalam in 1997 to that in 2000?
Offer a terse response. 0.59. What is the ratio of the Oil Rent (as % of GDP) of Kazakhstan in 1997 to that in 2000?
Ensure brevity in your answer.  0.41. What is the ratio of the Oil Rent (as % of GDP) in Netherlands in 1997 to that in 2000?
Offer a very short reply. 0.94. What is the ratio of the Oil Rent (as % of GDP) in Benin in 1997 to that in 2001?
Your answer should be compact. 1.66. What is the ratio of the Oil Rent (as % of GDP) of Brunei Darussalam in 1997 to that in 2001?
Your answer should be compact. 0.66. What is the ratio of the Oil Rent (as % of GDP) in Kazakhstan in 1997 to that in 2001?
Ensure brevity in your answer.  0.53. What is the ratio of the Oil Rent (as % of GDP) in Netherlands in 1997 to that in 2001?
Provide a short and direct response. 1.26. What is the ratio of the Oil Rent (as % of GDP) in Benin in 1997 to that in 2002?
Make the answer very short. 1.6. What is the ratio of the Oil Rent (as % of GDP) of Brunei Darussalam in 1997 to that in 2002?
Provide a succinct answer. 0.65. What is the ratio of the Oil Rent (as % of GDP) in Kazakhstan in 1997 to that in 2002?
Make the answer very short. 0.47. What is the ratio of the Oil Rent (as % of GDP) in Netherlands in 1997 to that in 2002?
Provide a succinct answer. 0.83. What is the ratio of the Oil Rent (as % of GDP) in Benin in 1997 to that in 2003?
Your response must be concise. 3.41. What is the ratio of the Oil Rent (as % of GDP) in Brunei Darussalam in 1997 to that in 2003?
Provide a short and direct response. 0.61. What is the ratio of the Oil Rent (as % of GDP) in Kazakhstan in 1997 to that in 2003?
Your response must be concise. 0.46. What is the ratio of the Oil Rent (as % of GDP) of Netherlands in 1997 to that in 2003?
Keep it short and to the point. 0.82. What is the ratio of the Oil Rent (as % of GDP) of Benin in 1998 to that in 1999?
Your answer should be very brief. 0.7. What is the ratio of the Oil Rent (as % of GDP) in Brunei Darussalam in 1998 to that in 1999?
Your answer should be very brief. 0.67. What is the ratio of the Oil Rent (as % of GDP) in Kazakhstan in 1998 to that in 1999?
Ensure brevity in your answer.  0.45. What is the ratio of the Oil Rent (as % of GDP) of Netherlands in 1998 to that in 1999?
Offer a very short reply. 0.74. What is the ratio of the Oil Rent (as % of GDP) in Benin in 1998 to that in 2000?
Offer a terse response. 0.54. What is the ratio of the Oil Rent (as % of GDP) in Brunei Darussalam in 1998 to that in 2000?
Offer a very short reply. 0.46. What is the ratio of the Oil Rent (as % of GDP) of Kazakhstan in 1998 to that in 2000?
Offer a terse response. 0.24. What is the ratio of the Oil Rent (as % of GDP) of Netherlands in 1998 to that in 2000?
Give a very brief answer. 0.42. What is the ratio of the Oil Rent (as % of GDP) of Benin in 1998 to that in 2001?
Offer a very short reply. 0.69. What is the ratio of the Oil Rent (as % of GDP) of Brunei Darussalam in 1998 to that in 2001?
Your response must be concise. 0.51. What is the ratio of the Oil Rent (as % of GDP) of Kazakhstan in 1998 to that in 2001?
Offer a very short reply. 0.32. What is the ratio of the Oil Rent (as % of GDP) in Netherlands in 1998 to that in 2001?
Make the answer very short. 0.56. What is the ratio of the Oil Rent (as % of GDP) in Benin in 1998 to that in 2002?
Make the answer very short. 0.67. What is the ratio of the Oil Rent (as % of GDP) of Brunei Darussalam in 1998 to that in 2002?
Ensure brevity in your answer.  0.5. What is the ratio of the Oil Rent (as % of GDP) of Kazakhstan in 1998 to that in 2002?
Ensure brevity in your answer.  0.28. What is the ratio of the Oil Rent (as % of GDP) of Netherlands in 1998 to that in 2002?
Make the answer very short. 0.37. What is the ratio of the Oil Rent (as % of GDP) of Benin in 1998 to that in 2003?
Your answer should be compact. 1.42. What is the ratio of the Oil Rent (as % of GDP) in Brunei Darussalam in 1998 to that in 2003?
Ensure brevity in your answer.  0.47. What is the ratio of the Oil Rent (as % of GDP) in Kazakhstan in 1998 to that in 2003?
Provide a short and direct response. 0.28. What is the ratio of the Oil Rent (as % of GDP) of Netherlands in 1998 to that in 2003?
Give a very brief answer. 0.36. What is the ratio of the Oil Rent (as % of GDP) of Benin in 1999 to that in 2000?
Offer a very short reply. 0.78. What is the ratio of the Oil Rent (as % of GDP) in Brunei Darussalam in 1999 to that in 2000?
Provide a short and direct response. 0.68. What is the ratio of the Oil Rent (as % of GDP) of Kazakhstan in 1999 to that in 2000?
Your answer should be compact. 0.55. What is the ratio of the Oil Rent (as % of GDP) of Netherlands in 1999 to that in 2000?
Offer a very short reply. 0.56. What is the ratio of the Oil Rent (as % of GDP) of Brunei Darussalam in 1999 to that in 2001?
Ensure brevity in your answer.  0.76. What is the ratio of the Oil Rent (as % of GDP) in Kazakhstan in 1999 to that in 2001?
Offer a terse response. 0.71. What is the ratio of the Oil Rent (as % of GDP) of Netherlands in 1999 to that in 2001?
Offer a terse response. 0.75. What is the ratio of the Oil Rent (as % of GDP) of Benin in 1999 to that in 2002?
Your answer should be compact. 0.95. What is the ratio of the Oil Rent (as % of GDP) of Brunei Darussalam in 1999 to that in 2002?
Your response must be concise. 0.75. What is the ratio of the Oil Rent (as % of GDP) in Kazakhstan in 1999 to that in 2002?
Provide a succinct answer. 0.64. What is the ratio of the Oil Rent (as % of GDP) of Netherlands in 1999 to that in 2002?
Keep it short and to the point. 0.5. What is the ratio of the Oil Rent (as % of GDP) in Benin in 1999 to that in 2003?
Give a very brief answer. 2.04. What is the ratio of the Oil Rent (as % of GDP) in Brunei Darussalam in 1999 to that in 2003?
Your answer should be very brief. 0.69. What is the ratio of the Oil Rent (as % of GDP) of Kazakhstan in 1999 to that in 2003?
Provide a succinct answer. 0.62. What is the ratio of the Oil Rent (as % of GDP) of Netherlands in 1999 to that in 2003?
Provide a succinct answer. 0.49. What is the ratio of the Oil Rent (as % of GDP) of Benin in 2000 to that in 2001?
Ensure brevity in your answer.  1.27. What is the ratio of the Oil Rent (as % of GDP) of Brunei Darussalam in 2000 to that in 2001?
Make the answer very short. 1.12. What is the ratio of the Oil Rent (as % of GDP) of Kazakhstan in 2000 to that in 2001?
Your answer should be very brief. 1.29. What is the ratio of the Oil Rent (as % of GDP) in Netherlands in 2000 to that in 2001?
Give a very brief answer. 1.34. What is the ratio of the Oil Rent (as % of GDP) in Benin in 2000 to that in 2002?
Offer a terse response. 1.22. What is the ratio of the Oil Rent (as % of GDP) of Brunei Darussalam in 2000 to that in 2002?
Provide a succinct answer. 1.1. What is the ratio of the Oil Rent (as % of GDP) of Kazakhstan in 2000 to that in 2002?
Your response must be concise. 1.16. What is the ratio of the Oil Rent (as % of GDP) in Netherlands in 2000 to that in 2002?
Ensure brevity in your answer.  0.88. What is the ratio of the Oil Rent (as % of GDP) of Benin in 2000 to that in 2003?
Keep it short and to the point. 2.61. What is the ratio of the Oil Rent (as % of GDP) in Brunei Darussalam in 2000 to that in 2003?
Your answer should be compact. 1.02. What is the ratio of the Oil Rent (as % of GDP) in Kazakhstan in 2000 to that in 2003?
Keep it short and to the point. 1.12. What is the ratio of the Oil Rent (as % of GDP) of Netherlands in 2000 to that in 2003?
Provide a succinct answer. 0.87. What is the ratio of the Oil Rent (as % of GDP) in Benin in 2001 to that in 2002?
Provide a succinct answer. 0.96. What is the ratio of the Oil Rent (as % of GDP) of Brunei Darussalam in 2001 to that in 2002?
Your answer should be compact. 0.99. What is the ratio of the Oil Rent (as % of GDP) of Kazakhstan in 2001 to that in 2002?
Your answer should be compact. 0.9. What is the ratio of the Oil Rent (as % of GDP) of Netherlands in 2001 to that in 2002?
Keep it short and to the point. 0.66. What is the ratio of the Oil Rent (as % of GDP) of Benin in 2001 to that in 2003?
Provide a succinct answer. 2.05. What is the ratio of the Oil Rent (as % of GDP) of Brunei Darussalam in 2001 to that in 2003?
Your response must be concise. 0.91. What is the ratio of the Oil Rent (as % of GDP) of Kazakhstan in 2001 to that in 2003?
Provide a short and direct response. 0.87. What is the ratio of the Oil Rent (as % of GDP) in Netherlands in 2001 to that in 2003?
Your answer should be compact. 0.65. What is the ratio of the Oil Rent (as % of GDP) in Benin in 2002 to that in 2003?
Provide a short and direct response. 2.13. What is the ratio of the Oil Rent (as % of GDP) in Brunei Darussalam in 2002 to that in 2003?
Offer a terse response. 0.93. What is the ratio of the Oil Rent (as % of GDP) of Kazakhstan in 2002 to that in 2003?
Your answer should be compact. 0.97. What is the ratio of the Oil Rent (as % of GDP) in Netherlands in 2002 to that in 2003?
Provide a short and direct response. 0.99. What is the difference between the highest and the second highest Oil Rent (as % of GDP) of Benin?
Offer a very short reply. 0.08. What is the difference between the highest and the second highest Oil Rent (as % of GDP) in Brunei Darussalam?
Offer a very short reply. 0.56. What is the difference between the highest and the second highest Oil Rent (as % of GDP) of Kazakhstan?
Your answer should be very brief. 3.95. What is the difference between the highest and the lowest Oil Rent (as % of GDP) in Benin?
Provide a succinct answer. 0.24. What is the difference between the highest and the lowest Oil Rent (as % of GDP) of Brunei Darussalam?
Make the answer very short. 15.28. What is the difference between the highest and the lowest Oil Rent (as % of GDP) of Kazakhstan?
Provide a short and direct response. 27.01. What is the difference between the highest and the lowest Oil Rent (as % of GDP) of Netherlands?
Give a very brief answer. 0.04. 